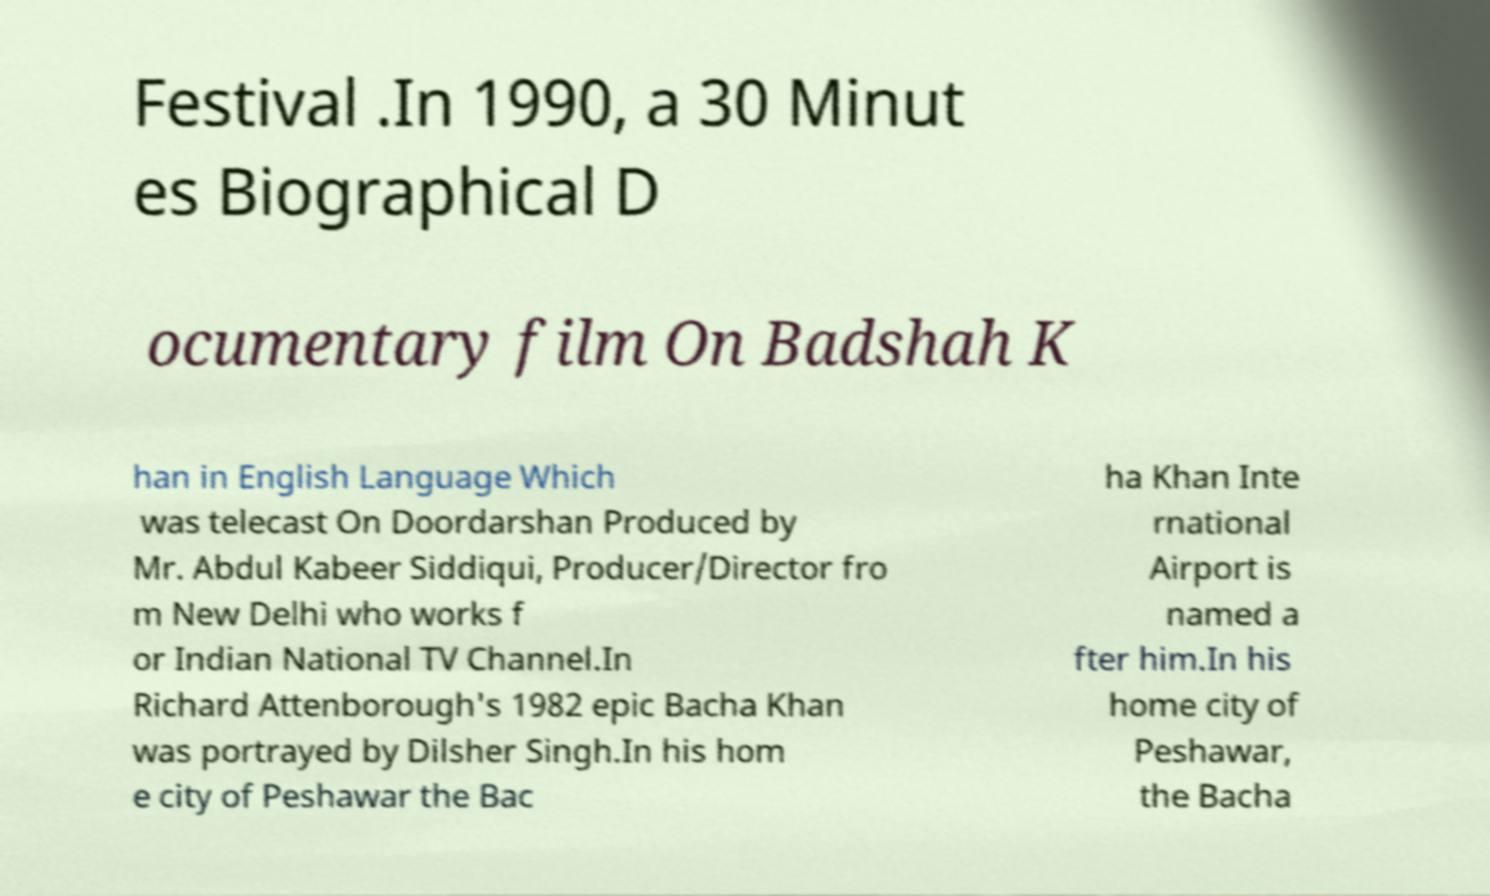Can you accurately transcribe the text from the provided image for me? Festival .In 1990, a 30 Minut es Biographical D ocumentary film On Badshah K han in English Language Which was telecast On Doordarshan Produced by Mr. Abdul Kabeer Siddiqui, Producer/Director fro m New Delhi who works f or Indian National TV Channel.In Richard Attenborough's 1982 epic Bacha Khan was portrayed by Dilsher Singh.In his hom e city of Peshawar the Bac ha Khan Inte rnational Airport is named a fter him.In his home city of Peshawar, the Bacha 